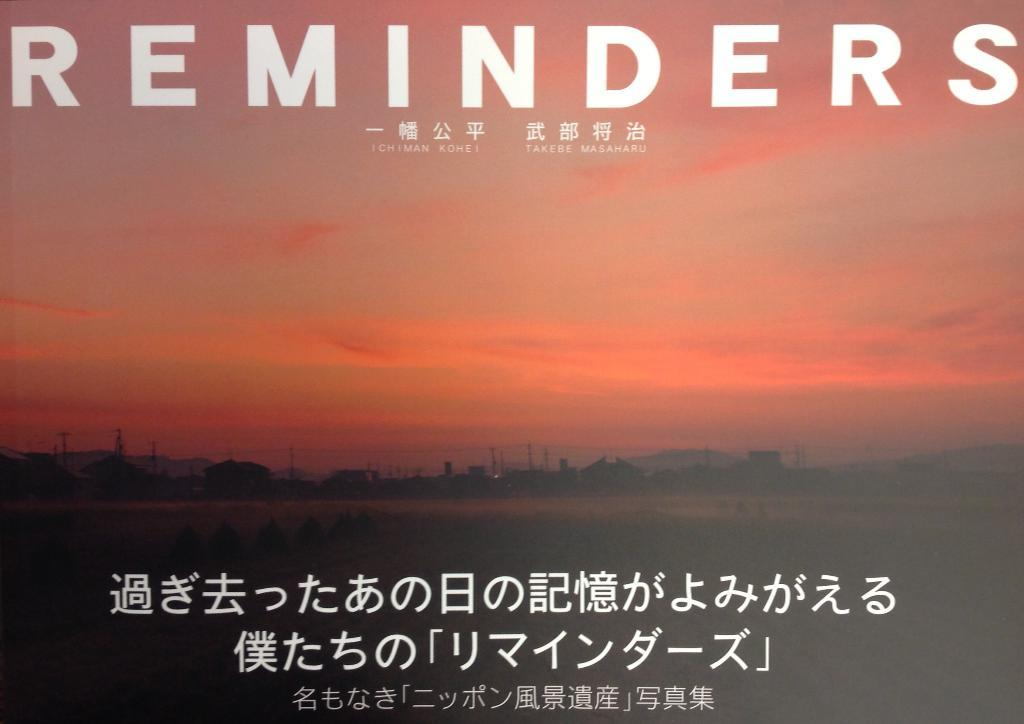<image>
Present a compact description of the photo's key features. A sunset with reminders as the title and other Asian writing. 